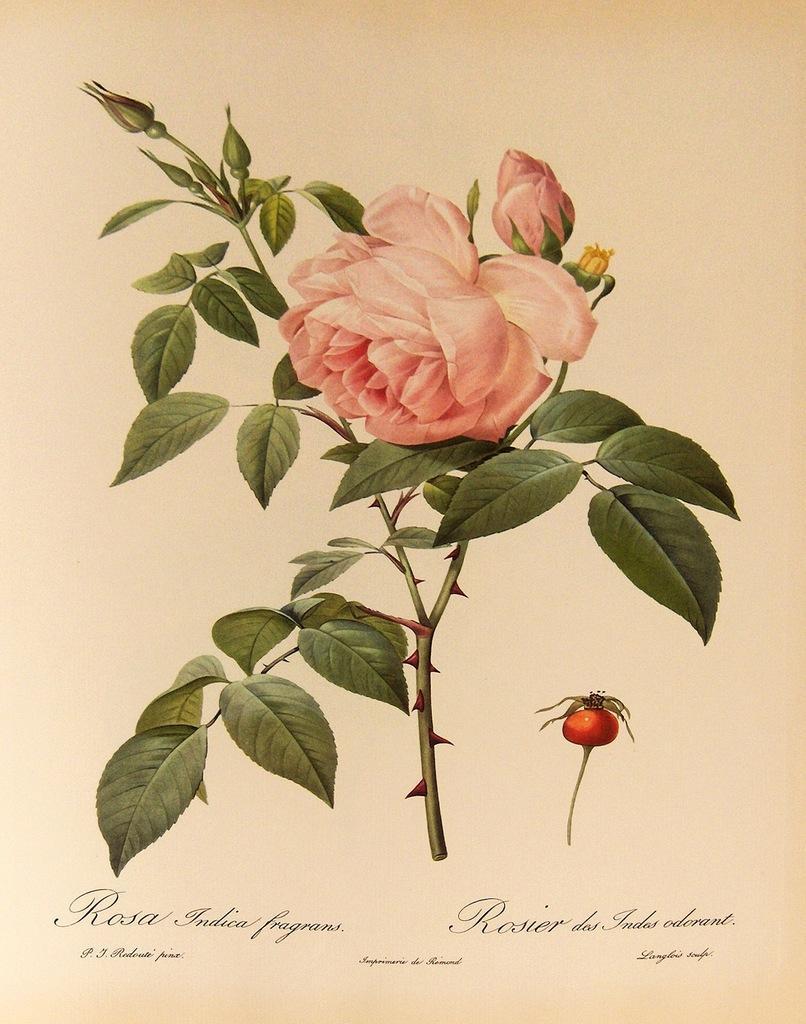Please provide a concise description of this image. This image is a painting. There is a flower plant in the center of the image. At the bottom of the image there is text printed. 